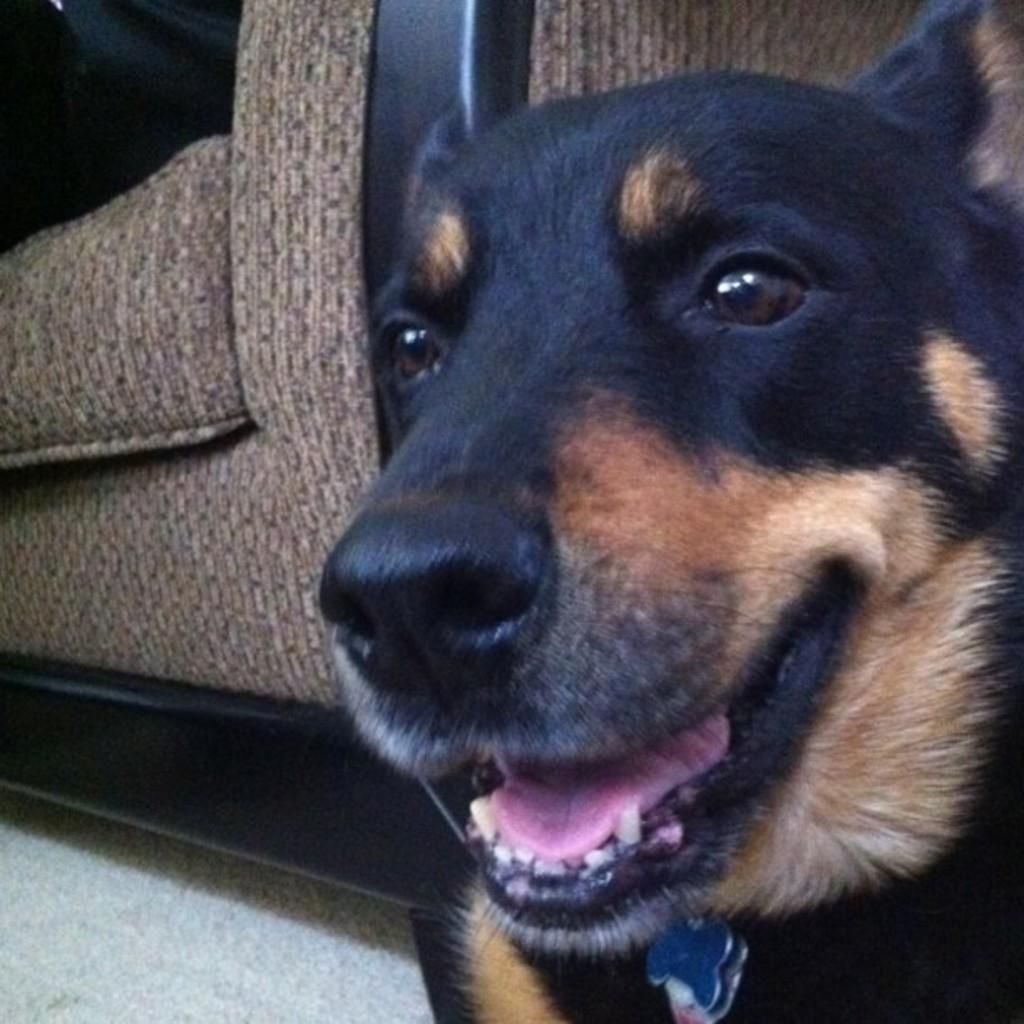What type of animal can be seen in the image? There is a dog in the image. What piece of furniture is visible in the background? There is a sofa in the background of the image. What part of the room is visible at the bottom of the image? The floor is visible at the bottom of the image. What type of feather can be seen on the dog's back in the image? There is no feather present on the dog's back in the image. What type of structure is visible in the background of the image? The image does not show any structures in the background; it only features a sofa. 